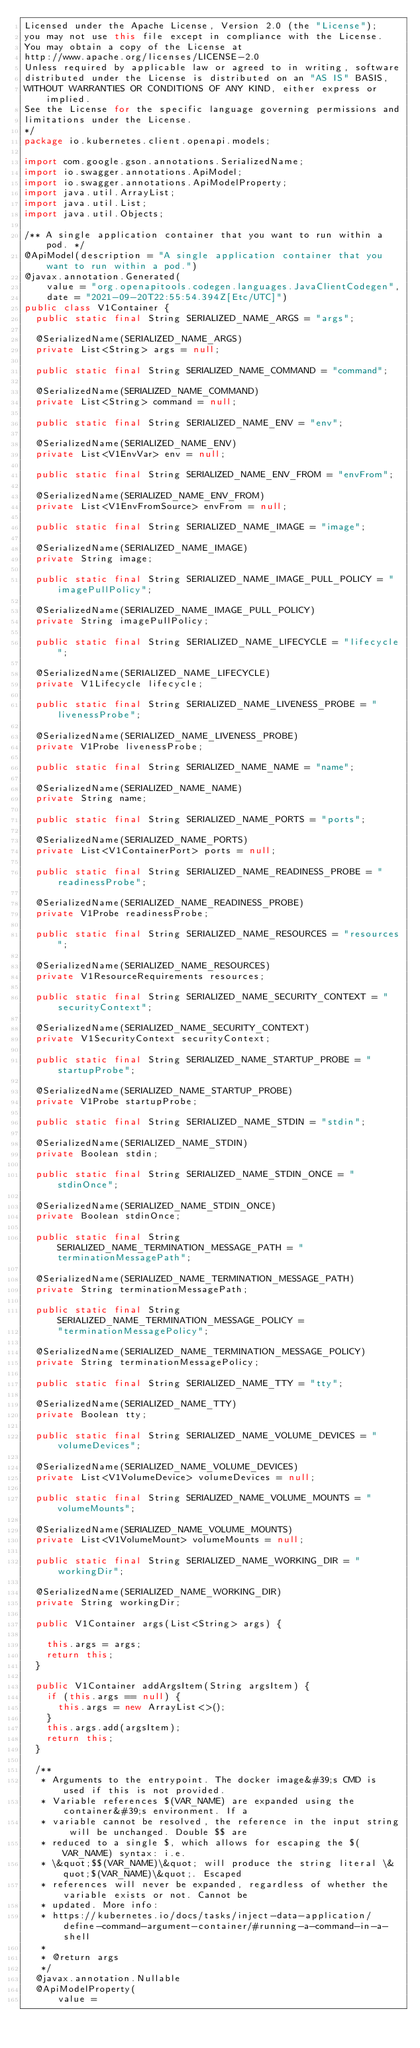Convert code to text. <code><loc_0><loc_0><loc_500><loc_500><_Java_>Licensed under the Apache License, Version 2.0 (the "License");
you may not use this file except in compliance with the License.
You may obtain a copy of the License at
http://www.apache.org/licenses/LICENSE-2.0
Unless required by applicable law or agreed to in writing, software
distributed under the License is distributed on an "AS IS" BASIS,
WITHOUT WARRANTIES OR CONDITIONS OF ANY KIND, either express or implied.
See the License for the specific language governing permissions and
limitations under the License.
*/
package io.kubernetes.client.openapi.models;

import com.google.gson.annotations.SerializedName;
import io.swagger.annotations.ApiModel;
import io.swagger.annotations.ApiModelProperty;
import java.util.ArrayList;
import java.util.List;
import java.util.Objects;

/** A single application container that you want to run within a pod. */
@ApiModel(description = "A single application container that you want to run within a pod.")
@javax.annotation.Generated(
    value = "org.openapitools.codegen.languages.JavaClientCodegen",
    date = "2021-09-20T22:55:54.394Z[Etc/UTC]")
public class V1Container {
  public static final String SERIALIZED_NAME_ARGS = "args";

  @SerializedName(SERIALIZED_NAME_ARGS)
  private List<String> args = null;

  public static final String SERIALIZED_NAME_COMMAND = "command";

  @SerializedName(SERIALIZED_NAME_COMMAND)
  private List<String> command = null;

  public static final String SERIALIZED_NAME_ENV = "env";

  @SerializedName(SERIALIZED_NAME_ENV)
  private List<V1EnvVar> env = null;

  public static final String SERIALIZED_NAME_ENV_FROM = "envFrom";

  @SerializedName(SERIALIZED_NAME_ENV_FROM)
  private List<V1EnvFromSource> envFrom = null;

  public static final String SERIALIZED_NAME_IMAGE = "image";

  @SerializedName(SERIALIZED_NAME_IMAGE)
  private String image;

  public static final String SERIALIZED_NAME_IMAGE_PULL_POLICY = "imagePullPolicy";

  @SerializedName(SERIALIZED_NAME_IMAGE_PULL_POLICY)
  private String imagePullPolicy;

  public static final String SERIALIZED_NAME_LIFECYCLE = "lifecycle";

  @SerializedName(SERIALIZED_NAME_LIFECYCLE)
  private V1Lifecycle lifecycle;

  public static final String SERIALIZED_NAME_LIVENESS_PROBE = "livenessProbe";

  @SerializedName(SERIALIZED_NAME_LIVENESS_PROBE)
  private V1Probe livenessProbe;

  public static final String SERIALIZED_NAME_NAME = "name";

  @SerializedName(SERIALIZED_NAME_NAME)
  private String name;

  public static final String SERIALIZED_NAME_PORTS = "ports";

  @SerializedName(SERIALIZED_NAME_PORTS)
  private List<V1ContainerPort> ports = null;

  public static final String SERIALIZED_NAME_READINESS_PROBE = "readinessProbe";

  @SerializedName(SERIALIZED_NAME_READINESS_PROBE)
  private V1Probe readinessProbe;

  public static final String SERIALIZED_NAME_RESOURCES = "resources";

  @SerializedName(SERIALIZED_NAME_RESOURCES)
  private V1ResourceRequirements resources;

  public static final String SERIALIZED_NAME_SECURITY_CONTEXT = "securityContext";

  @SerializedName(SERIALIZED_NAME_SECURITY_CONTEXT)
  private V1SecurityContext securityContext;

  public static final String SERIALIZED_NAME_STARTUP_PROBE = "startupProbe";

  @SerializedName(SERIALIZED_NAME_STARTUP_PROBE)
  private V1Probe startupProbe;

  public static final String SERIALIZED_NAME_STDIN = "stdin";

  @SerializedName(SERIALIZED_NAME_STDIN)
  private Boolean stdin;

  public static final String SERIALIZED_NAME_STDIN_ONCE = "stdinOnce";

  @SerializedName(SERIALIZED_NAME_STDIN_ONCE)
  private Boolean stdinOnce;

  public static final String SERIALIZED_NAME_TERMINATION_MESSAGE_PATH = "terminationMessagePath";

  @SerializedName(SERIALIZED_NAME_TERMINATION_MESSAGE_PATH)
  private String terminationMessagePath;

  public static final String SERIALIZED_NAME_TERMINATION_MESSAGE_POLICY =
      "terminationMessagePolicy";

  @SerializedName(SERIALIZED_NAME_TERMINATION_MESSAGE_POLICY)
  private String terminationMessagePolicy;

  public static final String SERIALIZED_NAME_TTY = "tty";

  @SerializedName(SERIALIZED_NAME_TTY)
  private Boolean tty;

  public static final String SERIALIZED_NAME_VOLUME_DEVICES = "volumeDevices";

  @SerializedName(SERIALIZED_NAME_VOLUME_DEVICES)
  private List<V1VolumeDevice> volumeDevices = null;

  public static final String SERIALIZED_NAME_VOLUME_MOUNTS = "volumeMounts";

  @SerializedName(SERIALIZED_NAME_VOLUME_MOUNTS)
  private List<V1VolumeMount> volumeMounts = null;

  public static final String SERIALIZED_NAME_WORKING_DIR = "workingDir";

  @SerializedName(SERIALIZED_NAME_WORKING_DIR)
  private String workingDir;

  public V1Container args(List<String> args) {

    this.args = args;
    return this;
  }

  public V1Container addArgsItem(String argsItem) {
    if (this.args == null) {
      this.args = new ArrayList<>();
    }
    this.args.add(argsItem);
    return this;
  }

  /**
   * Arguments to the entrypoint. The docker image&#39;s CMD is used if this is not provided.
   * Variable references $(VAR_NAME) are expanded using the container&#39;s environment. If a
   * variable cannot be resolved, the reference in the input string will be unchanged. Double $$ are
   * reduced to a single $, which allows for escaping the $(VAR_NAME) syntax: i.e.
   * \&quot;$$(VAR_NAME)\&quot; will produce the string literal \&quot;$(VAR_NAME)\&quot;. Escaped
   * references will never be expanded, regardless of whether the variable exists or not. Cannot be
   * updated. More info:
   * https://kubernetes.io/docs/tasks/inject-data-application/define-command-argument-container/#running-a-command-in-a-shell
   *
   * @return args
   */
  @javax.annotation.Nullable
  @ApiModelProperty(
      value =</code> 